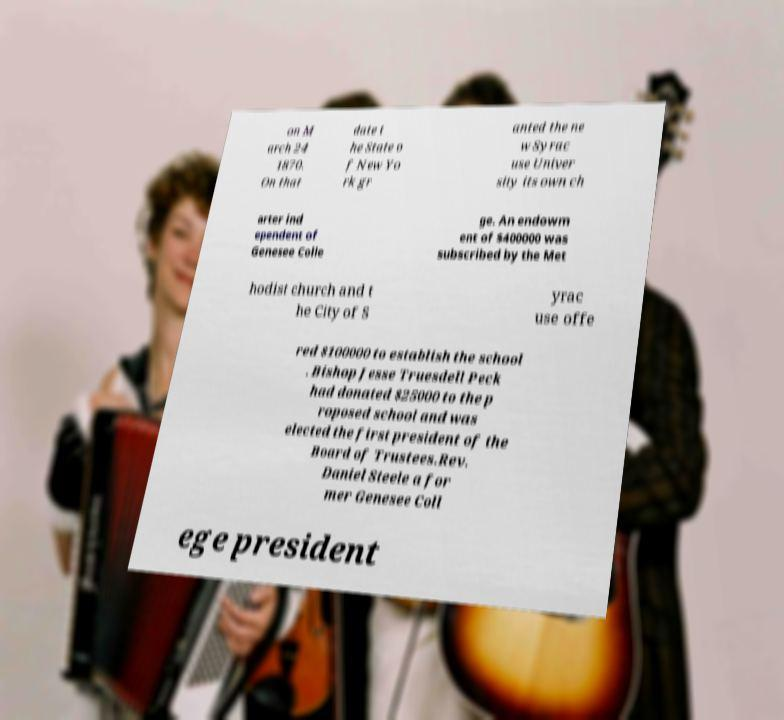Please read and relay the text visible in this image. What does it say? on M arch 24 1870. On that date t he State o f New Yo rk gr anted the ne w Syrac use Univer sity its own ch arter ind ependent of Genesee Colle ge. An endowm ent of $400000 was subscribed by the Met hodist church and t he City of S yrac use offe red $100000 to establish the school . Bishop Jesse Truesdell Peck had donated $25000 to the p roposed school and was elected the first president of the Board of Trustees.Rev. Daniel Steele a for mer Genesee Coll ege president 